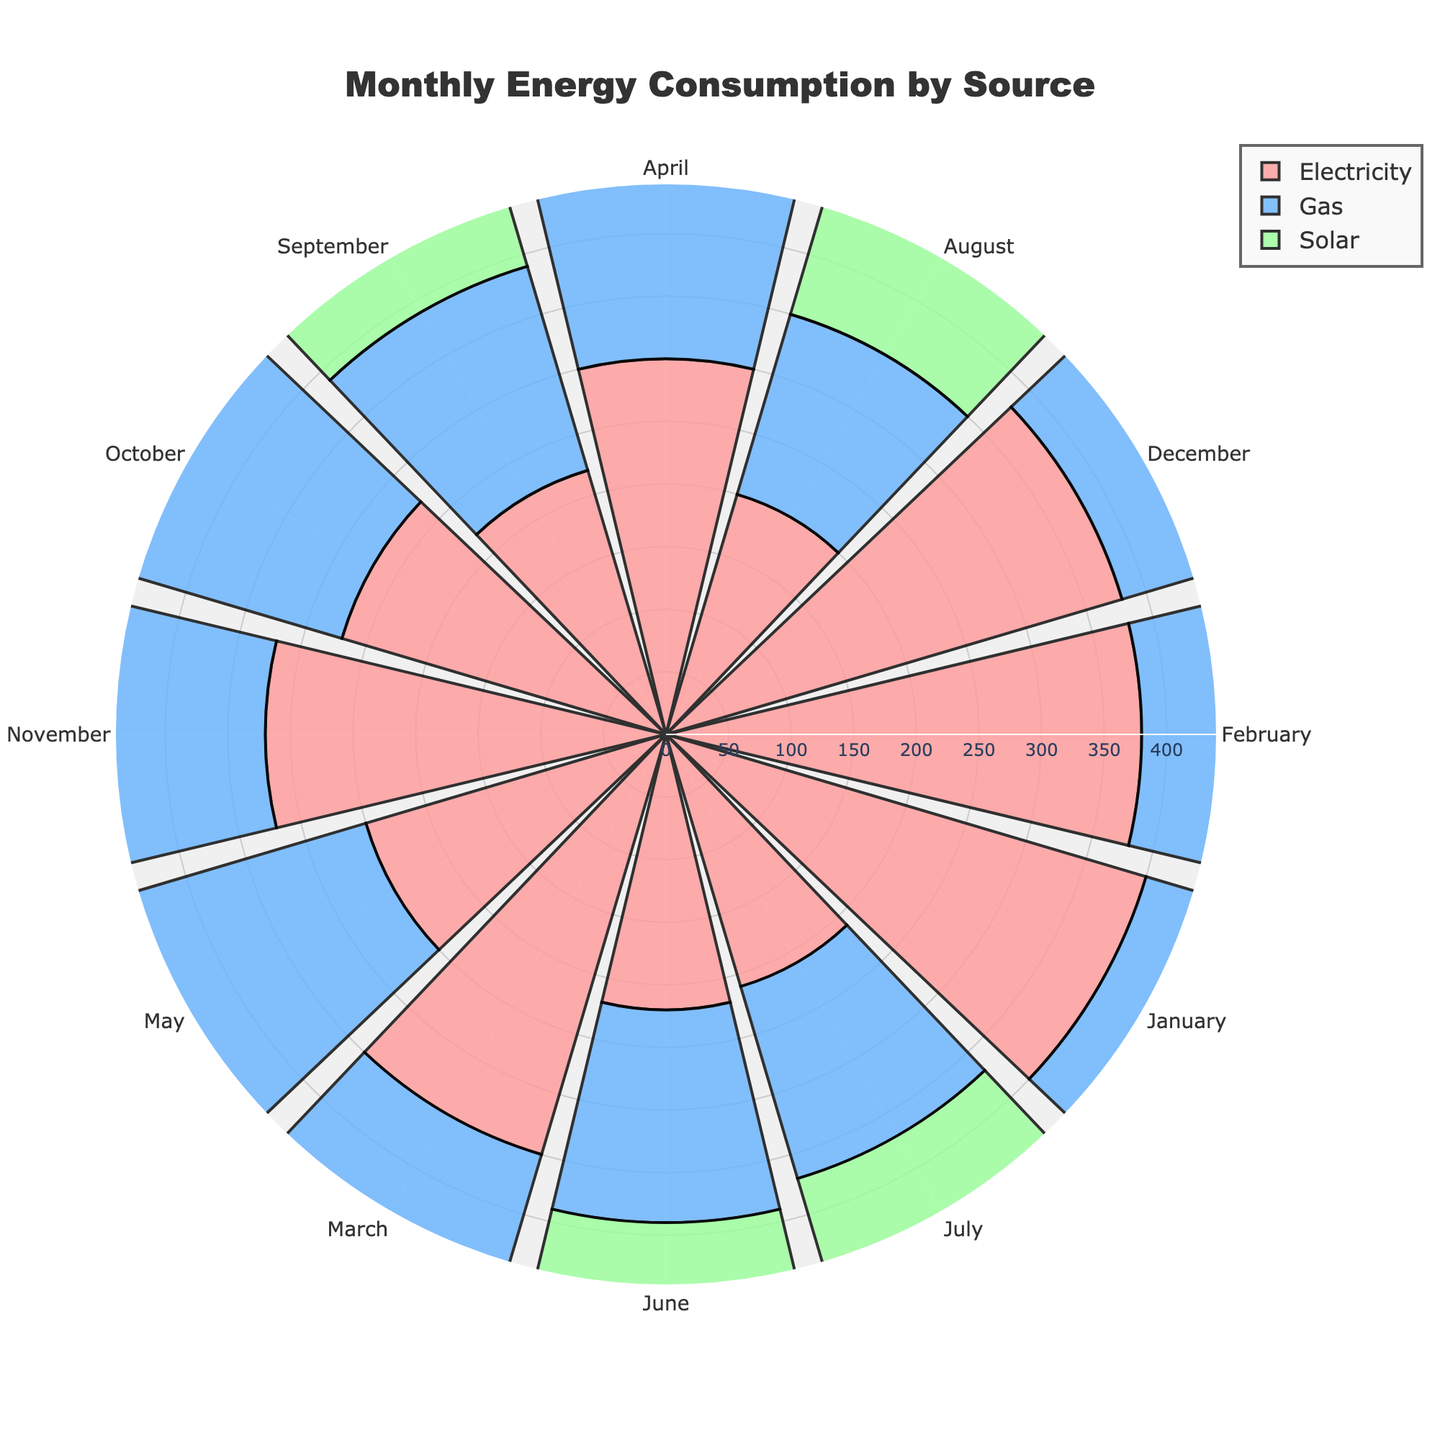What is the title of the rose chart? The title is located at the top center of the chart. Reading it directly gives you "Monthly Energy Consumption by Source".
Answer: "Monthly Energy Consumption by Source" What are the three energy sources represented in the chart? The chart legend includes the names of the energy sources, which are indicated by different colors. These are "Electricity", "Gas", and "Solar".
Answer: "Electricity", "Gas", "Solar" Which energy source had the highest consumption in January? By referring to the length of the colored bars in the January section, we can see that the 'Electricity' segment is the longest.
Answer: "Electricity" In which month did solar energy have the highest consumption? Looking at the green segments for each month, the segment in August is the longest.
Answer: "August" How did the consumption of electricity change from June to December? Comparing the length of the red segments from June to December shows an increase. June's segment is short, while December's is longer.
Answer: Increased What is the total energy consumption (sum) for each month from May to July? Sum the lengths of the segments for each source per month: May: 250 (Electricity) + 200 (Gas) + 120 (Solar) = 570; June: 220 (Electricity) + 170 (Gas) + 140 (Solar) = 530; July: 210 (Electricity) + 160 (Gas) + 150 (Solar) = 520.
Answer: May: 570, June: 530, July: 520 Which months exhibit the lowest gas consumption? Checking the shortest blue segments across all months leads to August and July having the smallest bars.
Answer: "August", "July" Compare the solar energy consumption in March and September. Which month has higher consumption? The green segments for March and September show that March is shorter with 70 kWh, and September has 130 kWh.
Answer: "September" Identify two months where the consumption of gas and solar combined is higher than that of electricity. Sum the lengths of blue and green segments for each month and compare to red: May (320 vs. 250), June (310 vs. 220), July (310 vs. 210), August (310 vs. 200). Hence May, June, July, and August combine to exceed electricity.
Answer: "May", "June", "July", "August" What is the average electricity consumption over the year? Add up the lengths of all red segments and divide by 12. (400+380+350+300+250+220+210+200+220+270+320+380) / 12 = 3200 / 12 = 266.67 kWh.
Answer: 266.67 kWh 